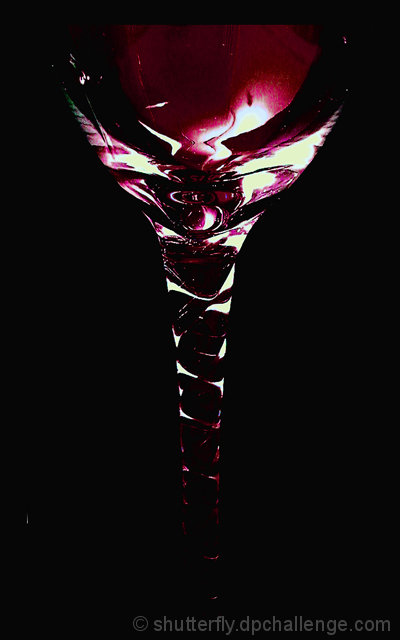Can you tell what beverage might be in the glass? Based on the deep red hue, it's conceivable that the beverage is a type of red wine, though the exact variety would be a guess without further information. 